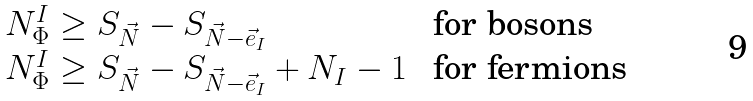<formula> <loc_0><loc_0><loc_500><loc_500>\begin{array} { l l } N ^ { I } _ { \Phi } \geq S _ { \vec { N } } - S _ { \vec { N } - \vec { e } _ { I } } & \text { for bosons} \\ N ^ { I } _ { \Phi } \geq S _ { \vec { N } } - S _ { \vec { N } - \vec { e } _ { I } } + N _ { I } - 1 & \text { for fermions} \end{array}</formula> 